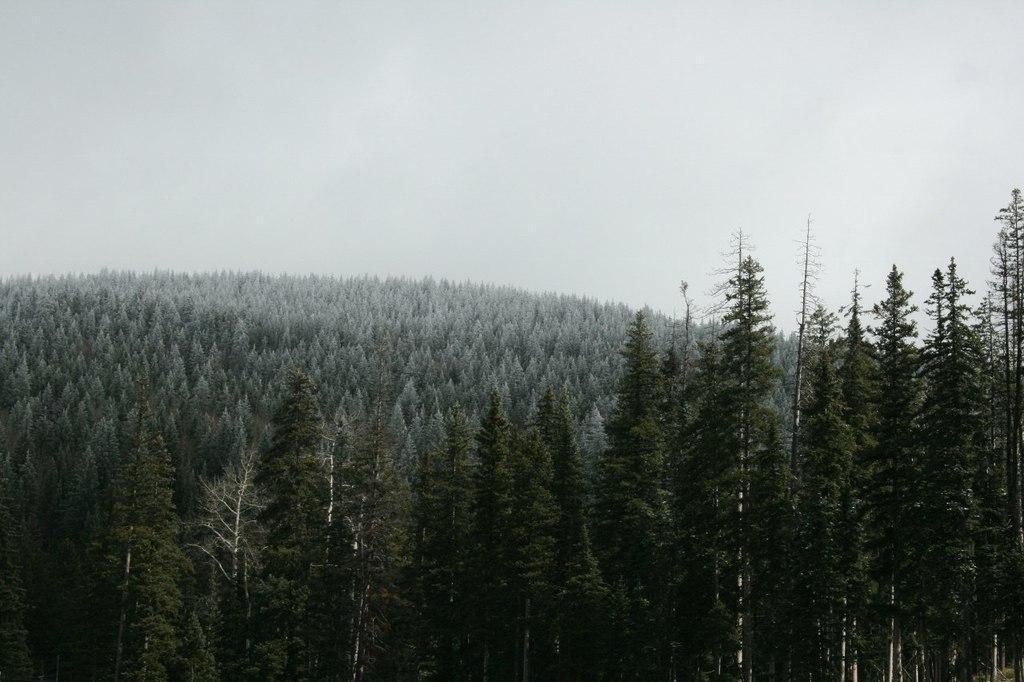In one or two sentences, can you explain what this image depicts? This image is taken outdoors. At the top of the image there is the sky with clouds. In the middle of the image there are many trees with leaves, stems and branches. 